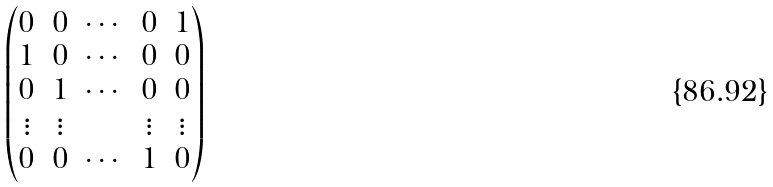Convert formula to latex. <formula><loc_0><loc_0><loc_500><loc_500>\begin{pmatrix} 0 & 0 & \cdots & 0 & 1 \\ 1 & 0 & \cdots & 0 & 0 \\ 0 & 1 & \cdots & 0 & 0 \\ \vdots & \vdots & & \vdots & \vdots \\ 0 & 0 & \cdots & 1 & 0 \end{pmatrix}</formula> 